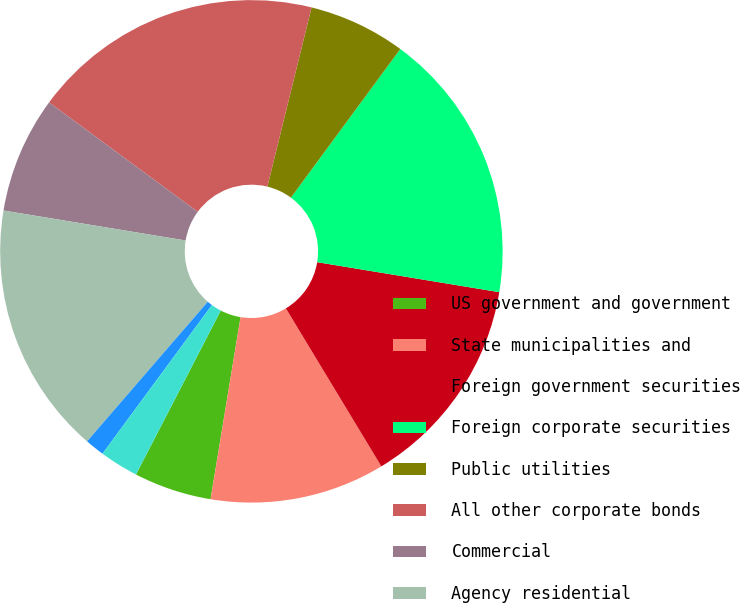Convert chart to OTSL. <chart><loc_0><loc_0><loc_500><loc_500><pie_chart><fcel>US government and government<fcel>State municipalities and<fcel>Foreign government securities<fcel>Foreign corporate securities<fcel>Public utilities<fcel>All other corporate bonds<fcel>Commercial<fcel>Agency residential<fcel>Non-agency residential<fcel>Redeemable preferred stock<nl><fcel>5.0%<fcel>11.25%<fcel>13.75%<fcel>17.5%<fcel>6.25%<fcel>18.75%<fcel>7.5%<fcel>16.25%<fcel>1.25%<fcel>2.5%<nl></chart> 